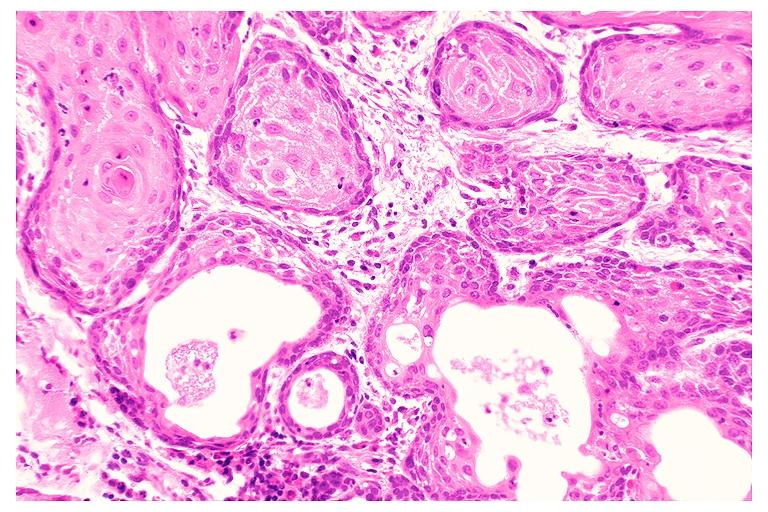s schwannoma present?
Answer the question using a single word or phrase. No 